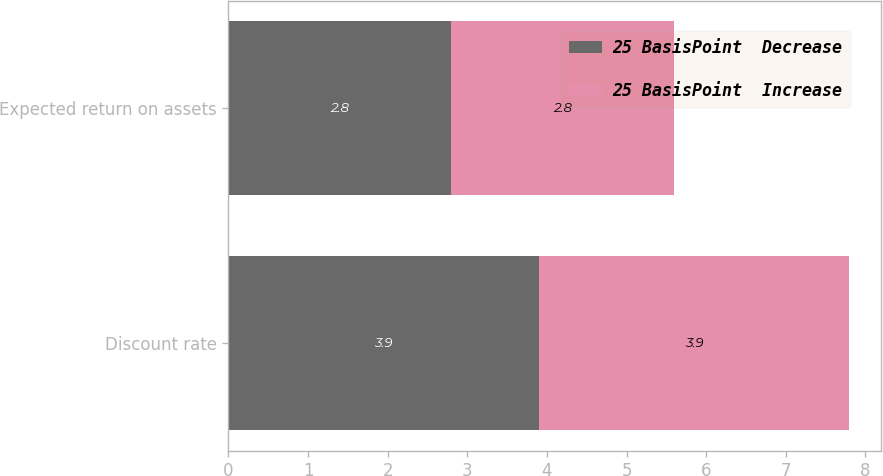Convert chart. <chart><loc_0><loc_0><loc_500><loc_500><stacked_bar_chart><ecel><fcel>Discount rate<fcel>Expected return on assets<nl><fcel>25 BasisPoint  Decrease<fcel>3.9<fcel>2.8<nl><fcel>25 BasisPoint  Increase<fcel>3.9<fcel>2.8<nl></chart> 